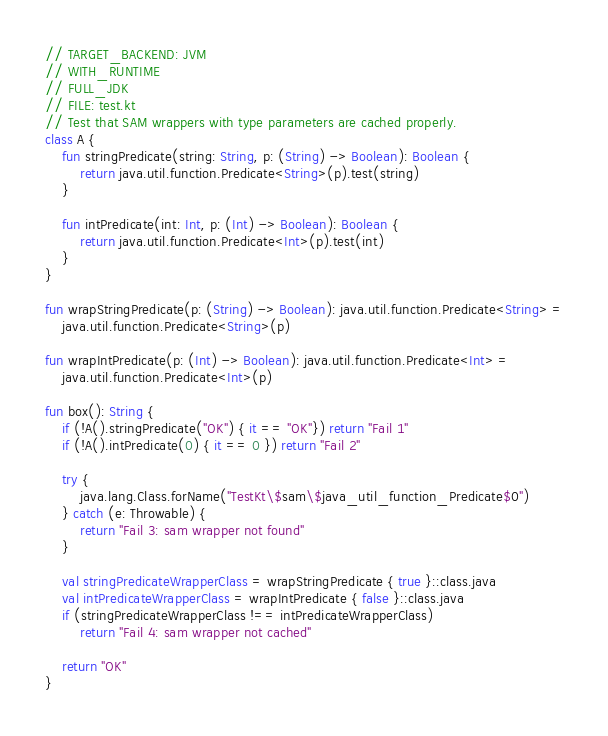<code> <loc_0><loc_0><loc_500><loc_500><_Kotlin_>// TARGET_BACKEND: JVM
// WITH_RUNTIME
// FULL_JDK
// FILE: test.kt
// Test that SAM wrappers with type parameters are cached properly.
class A {
    fun stringPredicate(string: String, p: (String) -> Boolean): Boolean {
        return java.util.function.Predicate<String>(p).test(string)
    }

    fun intPredicate(int: Int, p: (Int) -> Boolean): Boolean {
        return java.util.function.Predicate<Int>(p).test(int)
    }
}

fun wrapStringPredicate(p: (String) -> Boolean): java.util.function.Predicate<String> =
    java.util.function.Predicate<String>(p)

fun wrapIntPredicate(p: (Int) -> Boolean): java.util.function.Predicate<Int> =
    java.util.function.Predicate<Int>(p)

fun box(): String {
    if (!A().stringPredicate("OK") { it == "OK"}) return "Fail 1"
    if (!A().intPredicate(0) { it == 0 }) return "Fail 2"

    try {
        java.lang.Class.forName("TestKt\$sam\$java_util_function_Predicate$0")
    } catch (e: Throwable) {
        return "Fail 3: sam wrapper not found"
    }

    val stringPredicateWrapperClass = wrapStringPredicate { true }::class.java
    val intPredicateWrapperClass = wrapIntPredicate { false }::class.java
    if (stringPredicateWrapperClass !== intPredicateWrapperClass)
        return "Fail 4: sam wrapper not cached"

    return "OK"
}
</code> 